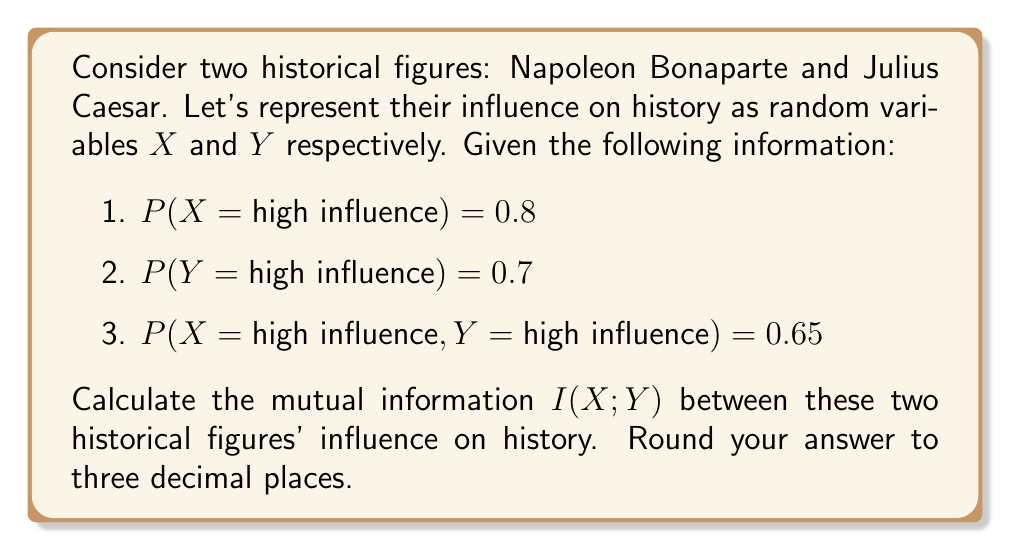Show me your answer to this math problem. To calculate the mutual information between Napoleon Bonaparte (X) and Julius Caesar (Y), we'll follow these steps:

1. First, let's recall the formula for mutual information:

   $$I(X;Y) = \sum_{x \in X} \sum_{y \in Y} p(x,y) \log_2 \left(\frac{p(x,y)}{p(x)p(y)}\right)$$

2. We need to calculate the joint and marginal probabilities:

   P(X = high) = 0.8
   P(X = low) = 1 - 0.8 = 0.2
   P(Y = high) = 0.7
   P(Y = low) = 1 - 0.7 = 0.3
   P(X = high, Y = high) = 0.65
   P(X = low, Y = low) = 1 - P(X = high) - P(Y = high) + P(X = high, Y = high) = 1 - 0.8 - 0.7 + 0.65 = 0.15
   P(X = high, Y = low) = P(X = high) - P(X = high, Y = high) = 0.8 - 0.65 = 0.15
   P(X = low, Y = high) = P(Y = high) - P(X = high, Y = high) = 0.7 - 0.65 = 0.05

3. Now, let's calculate each term of the sum:

   For X = high, Y = high:
   $$0.65 \log_2 \left(\frac{0.65}{0.8 \times 0.7}\right) = 0.65 \log_2 (1.1607) = 0.0984$$

   For X = high, Y = low:
   $$0.15 \log_2 \left(\frac{0.15}{0.8 \times 0.3}\right) = 0.15 \log_2 (0.625) = -0.0888$$

   For X = low, Y = high:
   $$0.05 \log_2 \left(\frac{0.05}{0.2 \times 0.7}\right) = 0.05 \log_2 (0.3571) = -0.0731$$

   For X = low, Y = low:
   $$0.15 \log_2 \left(\frac{0.15}{0.2 \times 0.3}\right) = 0.15 \log_2 (2.5) = 0.3479$$

4. Sum up all terms:

   $$I(X;Y) = 0.0984 - 0.0888 - 0.0731 + 0.3479 = 0.2844$$

5. Rounding to three decimal places:

   $$I(X;Y) \approx 0.284$$
Answer: 0.284 bits 